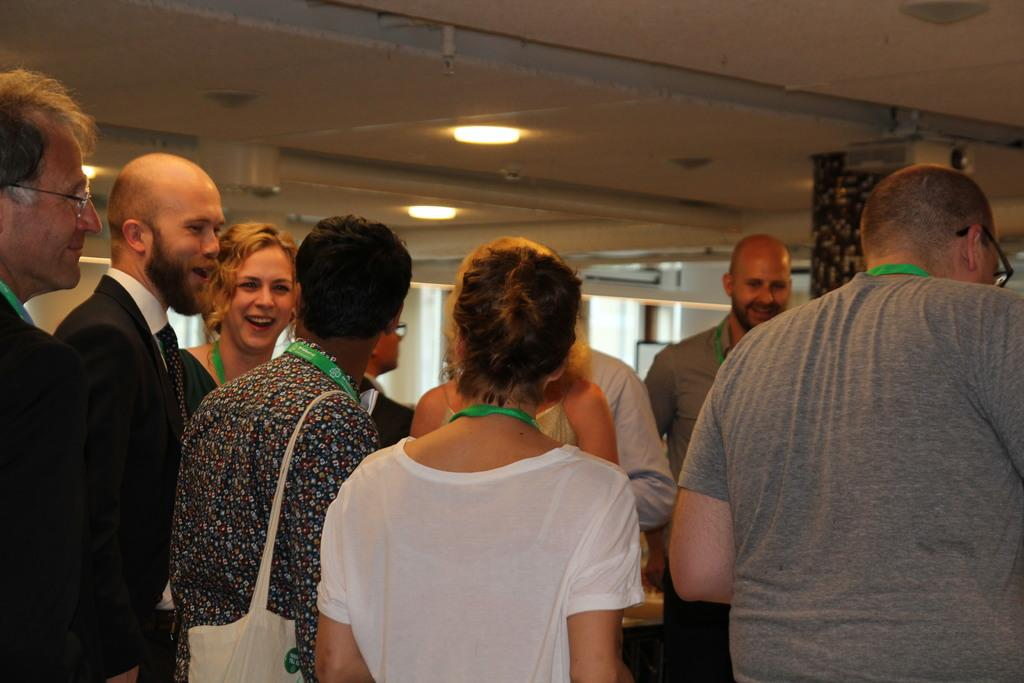What are the people in the image doing? The people in the image are standing and smiling. How can you tell that the people are smiling? The people are smiling because their facial expressions show happiness. What can be seen around the necks of the people in the image? The people are wearing identity cards around their necks. What is visible above the people in the image? There is a ceiling visible in the image, and lights are attached to the ceiling. What type of locket is hanging from the ceiling in the image? There is no locket hanging from the ceiling in the image; only lights are attached to the ceiling. How many mittens can be seen on the people in the image? There are no mittens visible in the image; the people are wearing identity cards around their necks. 